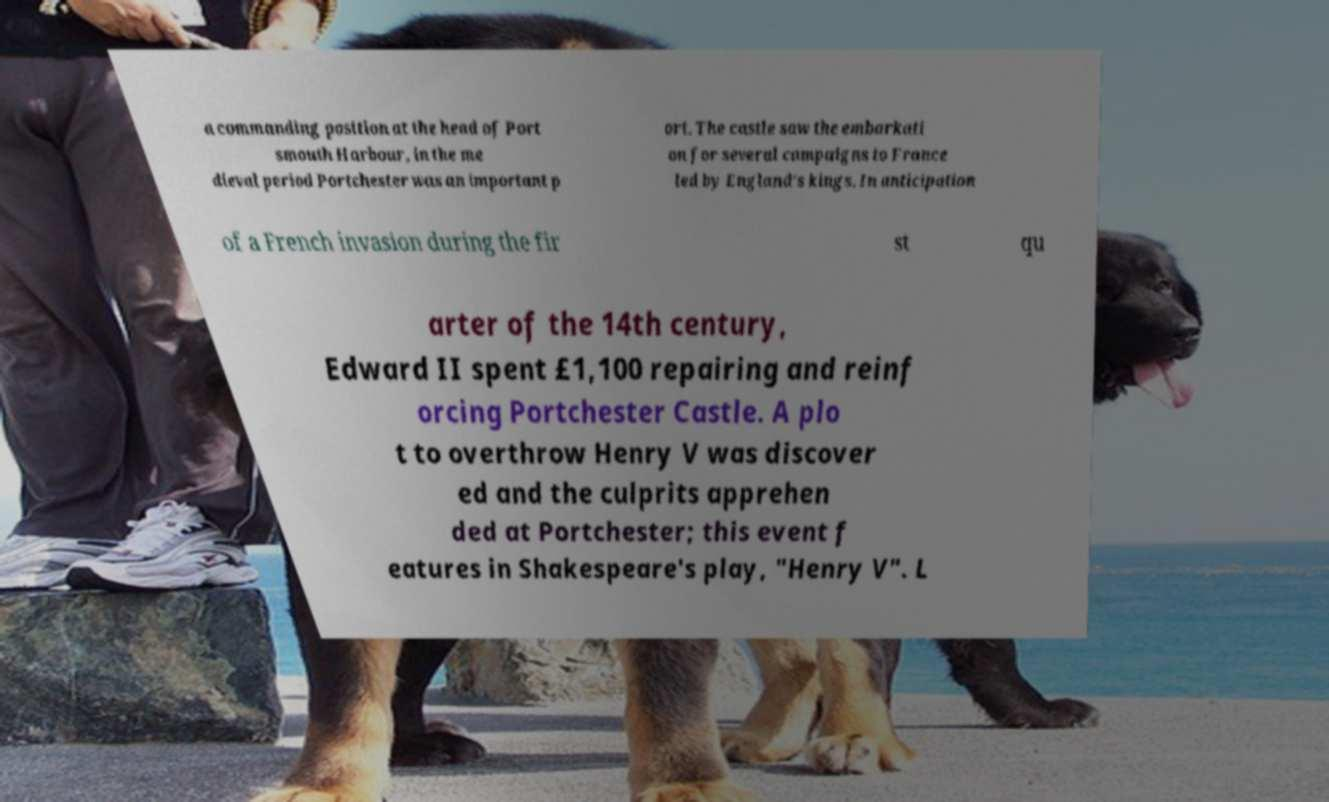I need the written content from this picture converted into text. Can you do that? a commanding position at the head of Port smouth Harbour, in the me dieval period Portchester was an important p ort. The castle saw the embarkati on for several campaigns to France led by England's kings. In anticipation of a French invasion during the fir st qu arter of the 14th century, Edward II spent £1,100 repairing and reinf orcing Portchester Castle. A plo t to overthrow Henry V was discover ed and the culprits apprehen ded at Portchester; this event f eatures in Shakespeare's play, "Henry V". L 